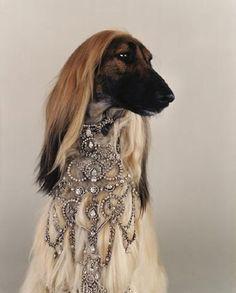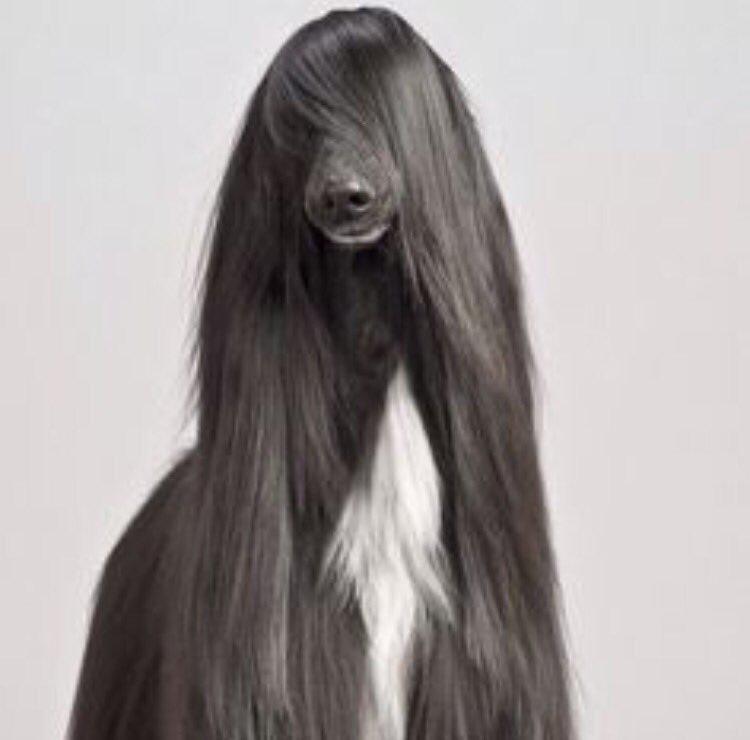The first image is the image on the left, the second image is the image on the right. For the images shown, is this caption "there us a dog wearing a necklace draped on it's neck" true? Answer yes or no. Yes. The first image is the image on the left, the second image is the image on the right. Considering the images on both sides, is "One of the dogs is wearing jewelry." valid? Answer yes or no. Yes. 